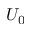Convert formula to latex. <formula><loc_0><loc_0><loc_500><loc_500>U _ { 0 }</formula> 